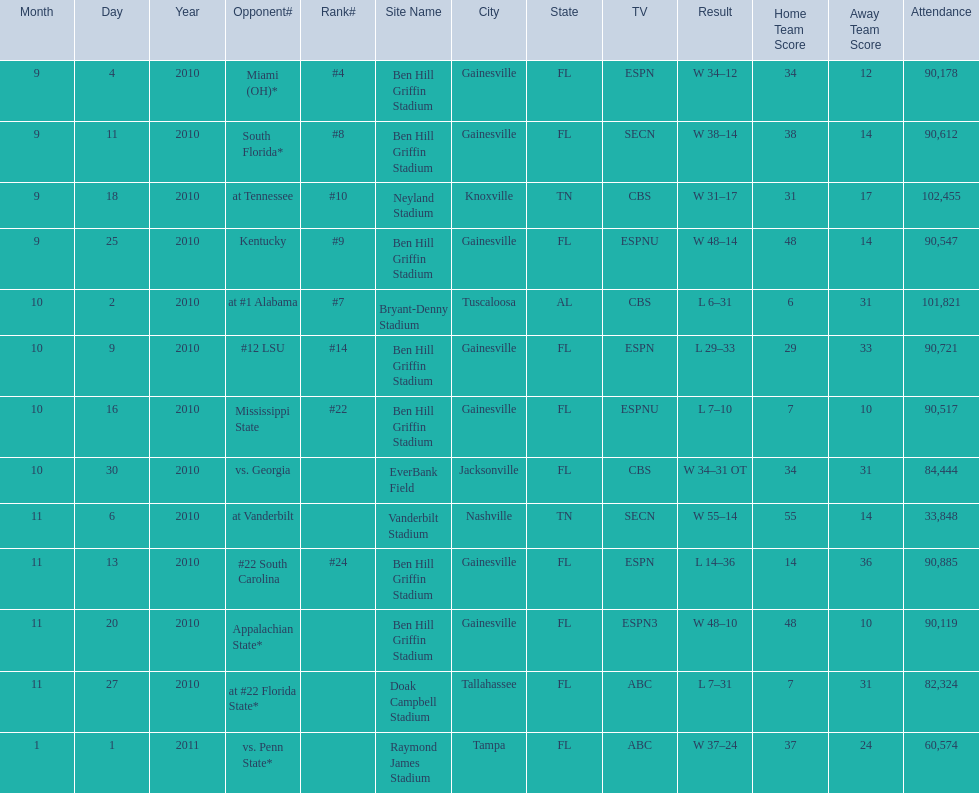How many consecutive weeks did the the gators win until the had their first lost in the 2010 season? 4. 